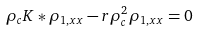<formula> <loc_0><loc_0><loc_500><loc_500>\rho _ { c } K * \rho _ { 1 , x x } - r \rho _ { c } ^ { 2 } \rho _ { 1 , x x } = 0</formula> 